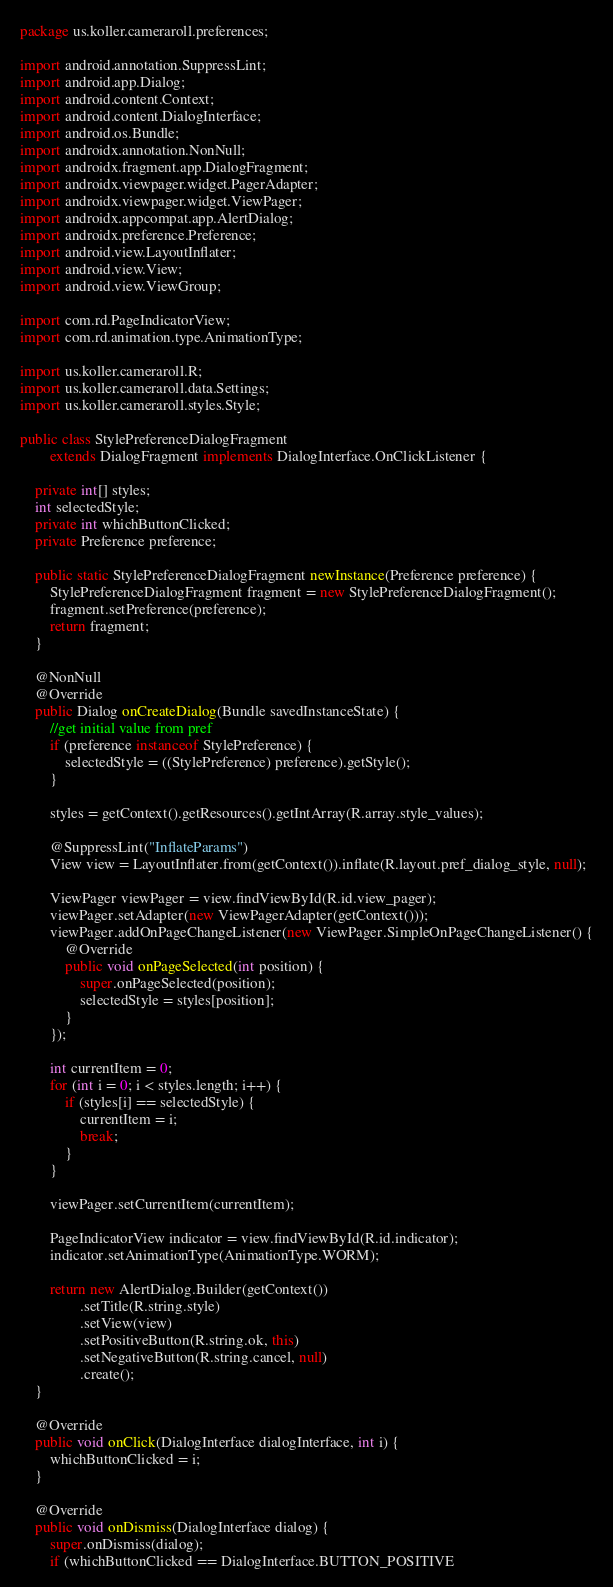<code> <loc_0><loc_0><loc_500><loc_500><_Java_>package us.koller.cameraroll.preferences;

import android.annotation.SuppressLint;
import android.app.Dialog;
import android.content.Context;
import android.content.DialogInterface;
import android.os.Bundle;
import androidx.annotation.NonNull;
import androidx.fragment.app.DialogFragment;
import androidx.viewpager.widget.PagerAdapter;
import androidx.viewpager.widget.ViewPager;
import androidx.appcompat.app.AlertDialog;
import androidx.preference.Preference;
import android.view.LayoutInflater;
import android.view.View;
import android.view.ViewGroup;

import com.rd.PageIndicatorView;
import com.rd.animation.type.AnimationType;

import us.koller.cameraroll.R;
import us.koller.cameraroll.data.Settings;
import us.koller.cameraroll.styles.Style;

public class StylePreferenceDialogFragment
        extends DialogFragment implements DialogInterface.OnClickListener {

    private int[] styles;
    int selectedStyle;
    private int whichButtonClicked;
    private Preference preference;

    public static StylePreferenceDialogFragment newInstance(Preference preference) {
        StylePreferenceDialogFragment fragment = new StylePreferenceDialogFragment();
        fragment.setPreference(preference);
        return fragment;
    }

    @NonNull
    @Override
    public Dialog onCreateDialog(Bundle savedInstanceState) {
        //get initial value from pref
        if (preference instanceof StylePreference) {
            selectedStyle = ((StylePreference) preference).getStyle();
        }

        styles = getContext().getResources().getIntArray(R.array.style_values);

        @SuppressLint("InflateParams")
        View view = LayoutInflater.from(getContext()).inflate(R.layout.pref_dialog_style, null);

        ViewPager viewPager = view.findViewById(R.id.view_pager);
        viewPager.setAdapter(new ViewPagerAdapter(getContext()));
        viewPager.addOnPageChangeListener(new ViewPager.SimpleOnPageChangeListener() {
            @Override
            public void onPageSelected(int position) {
                super.onPageSelected(position);
                selectedStyle = styles[position];
            }
        });

        int currentItem = 0;
        for (int i = 0; i < styles.length; i++) {
            if (styles[i] == selectedStyle) {
                currentItem = i;
                break;
            }
        }

        viewPager.setCurrentItem(currentItem);

        PageIndicatorView indicator = view.findViewById(R.id.indicator);
        indicator.setAnimationType(AnimationType.WORM);

        return new AlertDialog.Builder(getContext())
                .setTitle(R.string.style)
                .setView(view)
                .setPositiveButton(R.string.ok, this)
                .setNegativeButton(R.string.cancel, null)
                .create();
    }

    @Override
    public void onClick(DialogInterface dialogInterface, int i) {
        whichButtonClicked = i;
    }

    @Override
    public void onDismiss(DialogInterface dialog) {
        super.onDismiss(dialog);
        if (whichButtonClicked == DialogInterface.BUTTON_POSITIVE</code> 